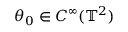Convert formula to latex. <formula><loc_0><loc_0><loc_500><loc_500>\theta _ { 0 } \in C ^ { \infty } ( { \mathbb { T } } ^ { 2 } )</formula> 